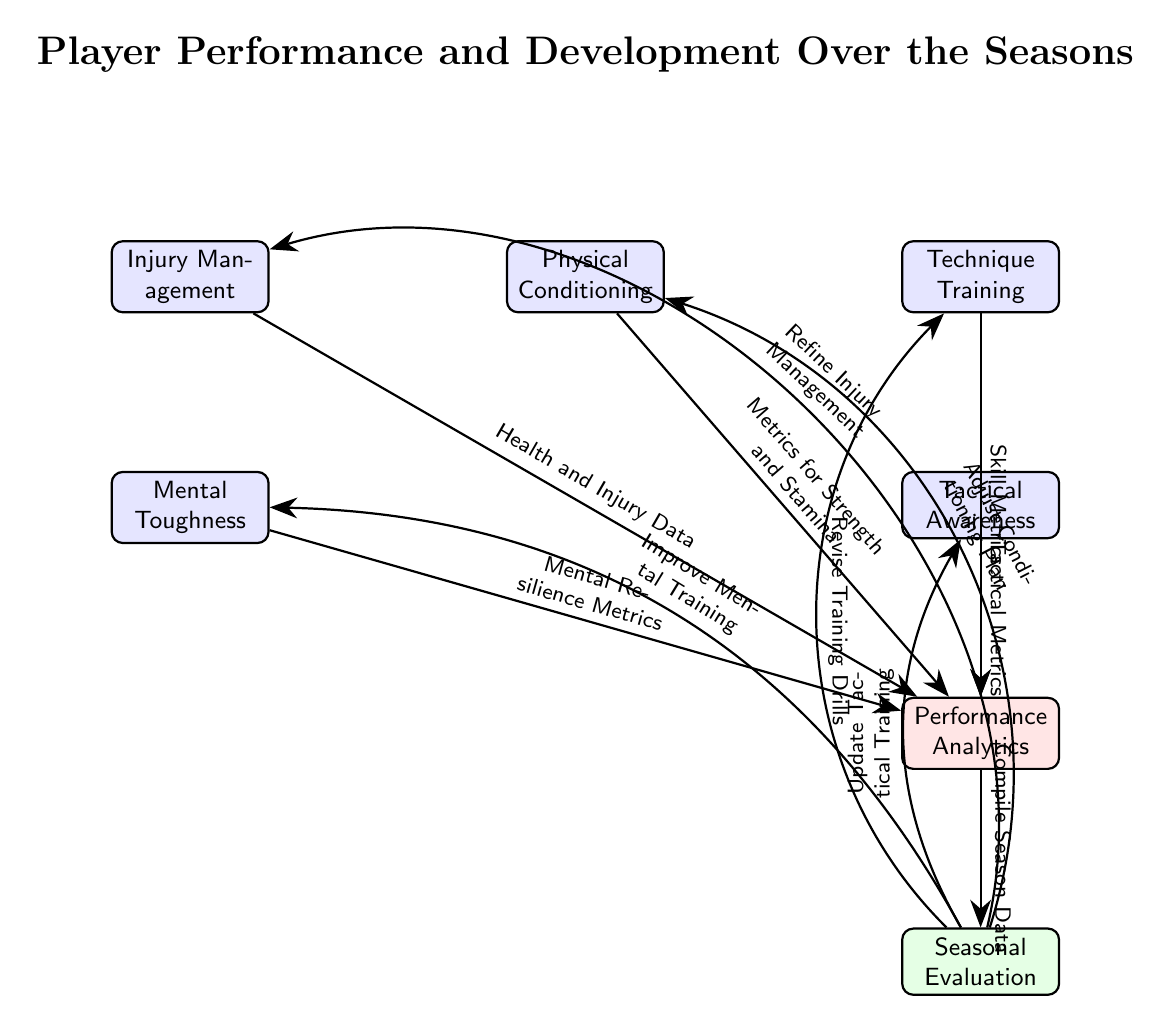What is the title of the diagram? The title of the diagram is shown at the top of the diagram above the first node, which is "Player Performance and Development Over the Seasons."
Answer: Player Performance and Development Over the Seasons How many main areas of player development are identified in the diagram? By counting the nodes directly connected and listed in the diagram, five main areas are identified: Physical Conditioning, Technique Training, Tactical Awareness, Mental Toughness, and Injury Management.
Answer: 5 What kind of metrics are associated with Tactical Awareness? The arrow leading from Tactical Awareness to Performance Analytics is labeled "Tactical Metrics," indicating that this is the associated metric.
Answer: Tactical Metrics Which area is directly linked to Seasonal Evaluation? There is an arrow moving from Performance Analytics to Seasonal Evaluation in the diagram, showing the link.
Answer: Performance Analytics What is the process following Seasonal Evaluation? After Seasonal Evaluation, the diagram specifies various adjustments to be made, indicating the need for updated training plans for different areas. This can be inferred from the arrows leading out from Seasonal Evaluation.
Answer: Adjust Conditioning Plan, Revise Training Drills, Update Tactical Training, Improve Mental Training, Refine Injury Management Which node is related to Health and Injury Data? Health and Injury Data is linked to Injury Management in the diagram, as indicated by the arrow connecting them.
Answer: Injury Management What is the relationship between Physical Conditioning and Performance Analytics? Physical Conditioning is linked to Performance Analytics through an edge marked "Metrics for Strength and Stamina," establishing a direct connection.
Answer: Metrics for Strength and Stamina How does the diagram indicate feedback into Physical Conditioning? The diagram shows a feedback loop coming from Seasonal Evaluation back into Physical Conditioning with an edge labeled "Adjust Conditioning Plan," indicating the relationship.
Answer: Adjust Conditioning Plan Which aspect of player development has the least number of connections in the diagram? By analyzing the nodes and their connections, Mental Toughness has only one direct link to Performance Analytics, making it the area with the least connections.
Answer: Mental Toughness 